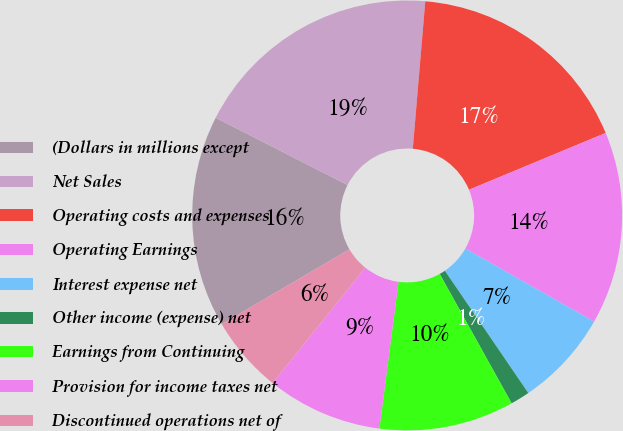<chart> <loc_0><loc_0><loc_500><loc_500><pie_chart><fcel>(Dollars in millions except<fcel>Net Sales<fcel>Operating costs and expenses<fcel>Operating Earnings<fcel>Interest expense net<fcel>Other income (expense) net<fcel>Earnings from Continuing<fcel>Provision for income taxes net<fcel>Discontinued operations net of<nl><fcel>15.94%<fcel>18.84%<fcel>17.39%<fcel>14.49%<fcel>7.25%<fcel>1.45%<fcel>10.14%<fcel>8.7%<fcel>5.8%<nl></chart> 